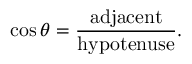Convert formula to latex. <formula><loc_0><loc_0><loc_500><loc_500>\cos \theta = { \frac { a d j a c e n t } { h y p o t e n u s e } } .</formula> 